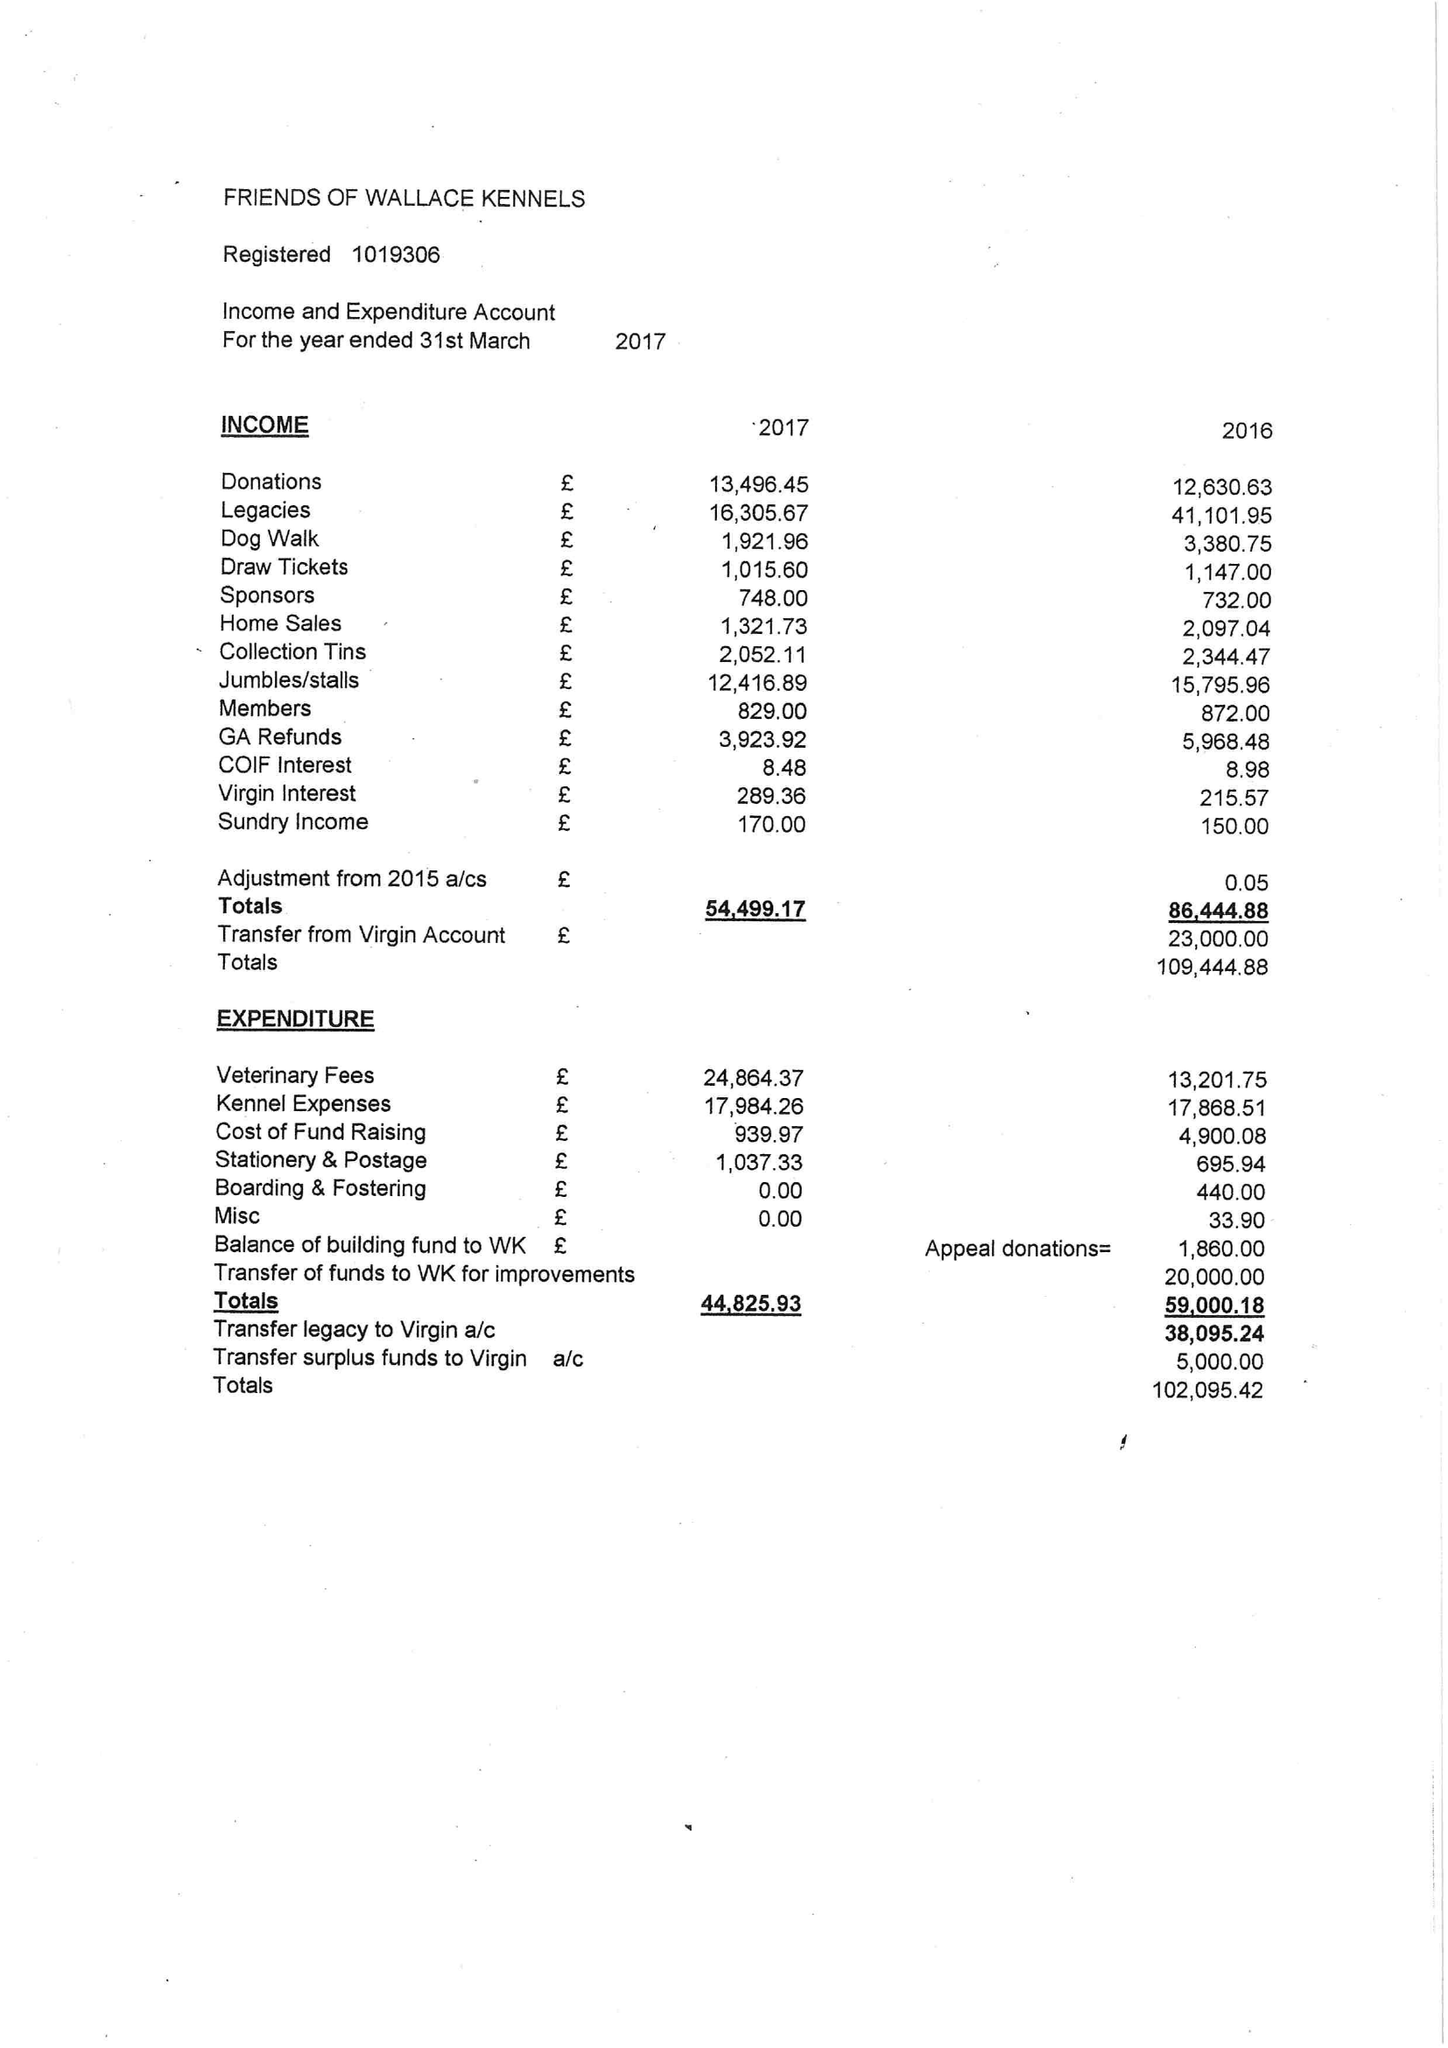What is the value for the spending_annually_in_british_pounds?
Answer the question using a single word or phrase. 44826.00 